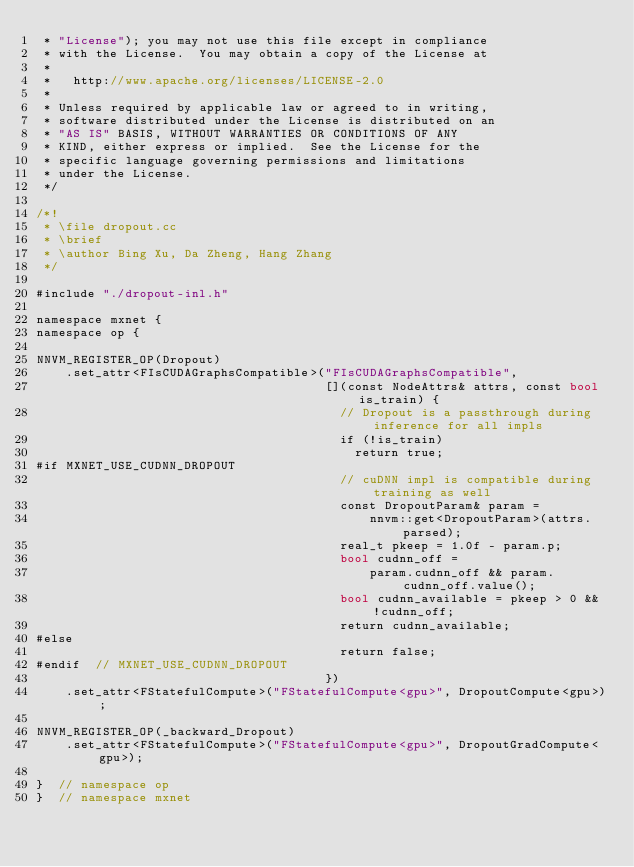Convert code to text. <code><loc_0><loc_0><loc_500><loc_500><_Cuda_> * "License"); you may not use this file except in compliance
 * with the License.  You may obtain a copy of the License at
 *
 *   http://www.apache.org/licenses/LICENSE-2.0
 *
 * Unless required by applicable law or agreed to in writing,
 * software distributed under the License is distributed on an
 * "AS IS" BASIS, WITHOUT WARRANTIES OR CONDITIONS OF ANY
 * KIND, either express or implied.  See the License for the
 * specific language governing permissions and limitations
 * under the License.
 */

/*!
 * \file dropout.cc
 * \brief
 * \author Bing Xu, Da Zheng, Hang Zhang
 */

#include "./dropout-inl.h"

namespace mxnet {
namespace op {

NNVM_REGISTER_OP(Dropout)
    .set_attr<FIsCUDAGraphsCompatible>("FIsCUDAGraphsCompatible",
                                       [](const NodeAttrs& attrs, const bool is_train) {
                                         // Dropout is a passthrough during inference for all impls
                                         if (!is_train)
                                           return true;
#if MXNET_USE_CUDNN_DROPOUT
                                         // cuDNN impl is compatible during training as well
                                         const DropoutParam& param =
                                             nnvm::get<DropoutParam>(attrs.parsed);
                                         real_t pkeep = 1.0f - param.p;
                                         bool cudnn_off =
                                             param.cudnn_off && param.cudnn_off.value();
                                         bool cudnn_available = pkeep > 0 && !cudnn_off;
                                         return cudnn_available;
#else
                                         return false;
#endif  // MXNET_USE_CUDNN_DROPOUT
                                       })
    .set_attr<FStatefulCompute>("FStatefulCompute<gpu>", DropoutCompute<gpu>);

NNVM_REGISTER_OP(_backward_Dropout)
    .set_attr<FStatefulCompute>("FStatefulCompute<gpu>", DropoutGradCompute<gpu>);

}  // namespace op
}  // namespace mxnet
</code> 